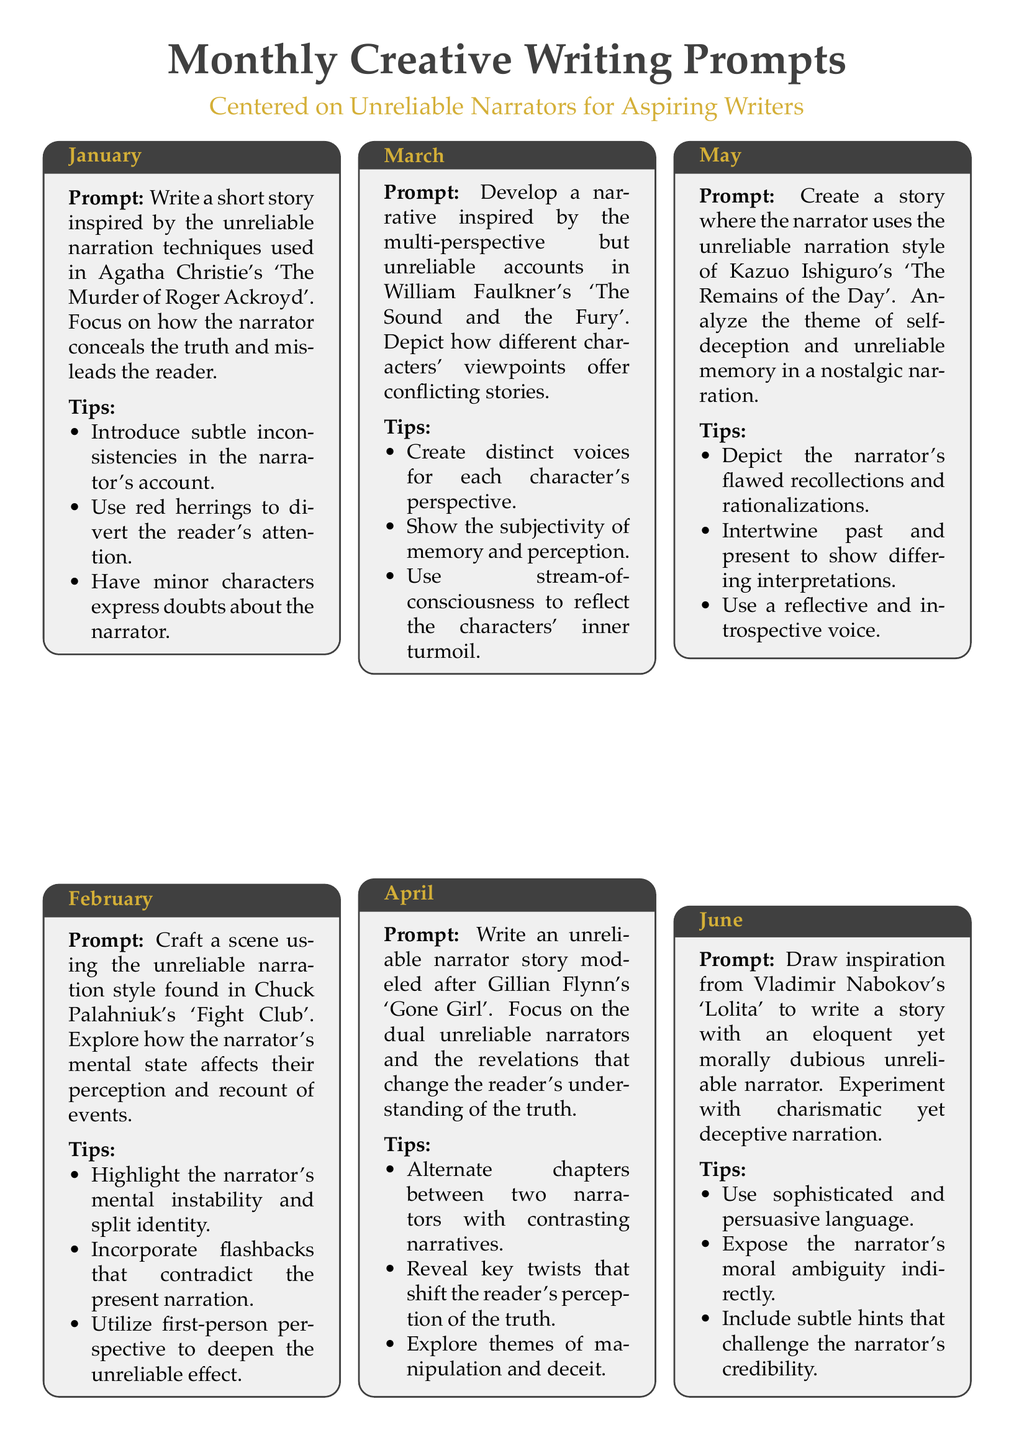What is the theme of the January prompt? The January prompt revolves around unreliable narration techniques in Agatha Christie's work.
Answer: Unreliable narration What narrative style is suggested in the February prompt? The February prompt suggests exploring the narration style from Chuck Palahniuk's "Fight Club".
Answer: First-person perspective Which author is associated with the March writing prompt? The author linked to the March prompt is William Faulkner.
Answer: William Faulkner How many prompts are focused on the theme of self-deception? The document contains one prompt specifically dealing with self-deception, found in May.
Answer: One prompt What common element does the April prompt share with the July prompt? Both the April and July prompts involve dual or multiple narrators uncovering deeper truths.
Answer: Dual narrators Which story is referenced for the June prompt regarding a morally dubious narrator? The June prompt references Vladimir Nabokov's "Lolita".
Answer: Lolita How does the August prompt approach the theme of mental health? The August prompt addresses mental health by exploring narrative reliability stemming from institutionalization.
Answer: Institutionalization In which month is the prompt that focuses on romantic obsession? The prompt regarding romantic obsession is scheduled for September.
Answer: September What genre does the October prompt's narrator embody? The October prompt's narrator embodies a biased and naive perspective, reflecting gothic elements.
Answer: Gothic elements 